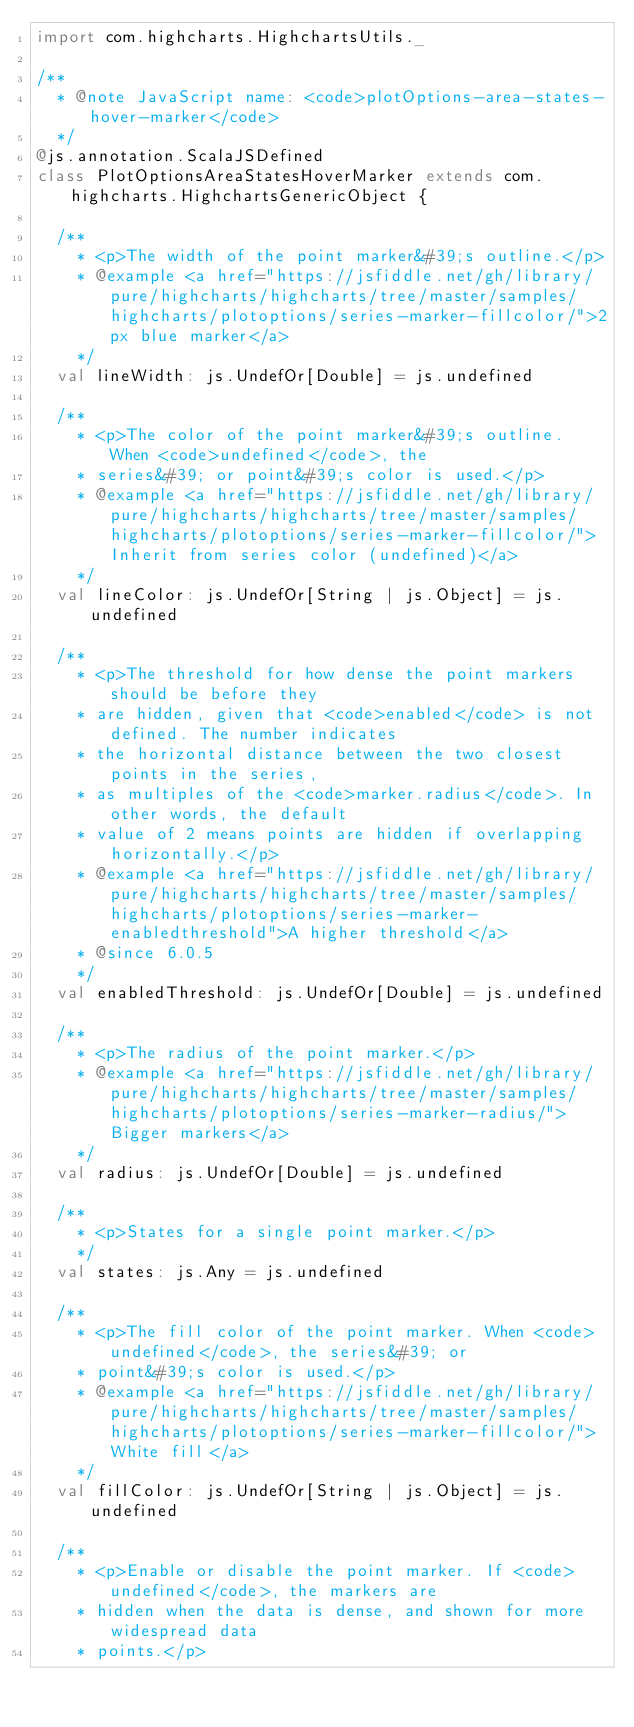<code> <loc_0><loc_0><loc_500><loc_500><_Scala_>import com.highcharts.HighchartsUtils._

/**
  * @note JavaScript name: <code>plotOptions-area-states-hover-marker</code>
  */
@js.annotation.ScalaJSDefined
class PlotOptionsAreaStatesHoverMarker extends com.highcharts.HighchartsGenericObject {

  /**
    * <p>The width of the point marker&#39;s outline.</p>
    * @example <a href="https://jsfiddle.net/gh/library/pure/highcharts/highcharts/tree/master/samples/highcharts/plotoptions/series-marker-fillcolor/">2px blue marker</a>
    */
  val lineWidth: js.UndefOr[Double] = js.undefined

  /**
    * <p>The color of the point marker&#39;s outline. When <code>undefined</code>, the
    * series&#39; or point&#39;s color is used.</p>
    * @example <a href="https://jsfiddle.net/gh/library/pure/highcharts/highcharts/tree/master/samples/highcharts/plotoptions/series-marker-fillcolor/">Inherit from series color (undefined)</a>
    */
  val lineColor: js.UndefOr[String | js.Object] = js.undefined

  /**
    * <p>The threshold for how dense the point markers should be before they
    * are hidden, given that <code>enabled</code> is not defined. The number indicates
    * the horizontal distance between the two closest points in the series,
    * as multiples of the <code>marker.radius</code>. In other words, the default
    * value of 2 means points are hidden if overlapping horizontally.</p>
    * @example <a href="https://jsfiddle.net/gh/library/pure/highcharts/highcharts/tree/master/samples/highcharts/plotoptions/series-marker-enabledthreshold">A higher threshold</a>
    * @since 6.0.5
    */
  val enabledThreshold: js.UndefOr[Double] = js.undefined

  /**
    * <p>The radius of the point marker.</p>
    * @example <a href="https://jsfiddle.net/gh/library/pure/highcharts/highcharts/tree/master/samples/highcharts/plotoptions/series-marker-radius/">Bigger markers</a>
    */
  val radius: js.UndefOr[Double] = js.undefined

  /**
    * <p>States for a single point marker.</p>
    */
  val states: js.Any = js.undefined

  /**
    * <p>The fill color of the point marker. When <code>undefined</code>, the series&#39; or
    * point&#39;s color is used.</p>
    * @example <a href="https://jsfiddle.net/gh/library/pure/highcharts/highcharts/tree/master/samples/highcharts/plotoptions/series-marker-fillcolor/">White fill</a>
    */
  val fillColor: js.UndefOr[String | js.Object] = js.undefined

  /**
    * <p>Enable or disable the point marker. If <code>undefined</code>, the markers are
    * hidden when the data is dense, and shown for more widespread data
    * points.</p></code> 